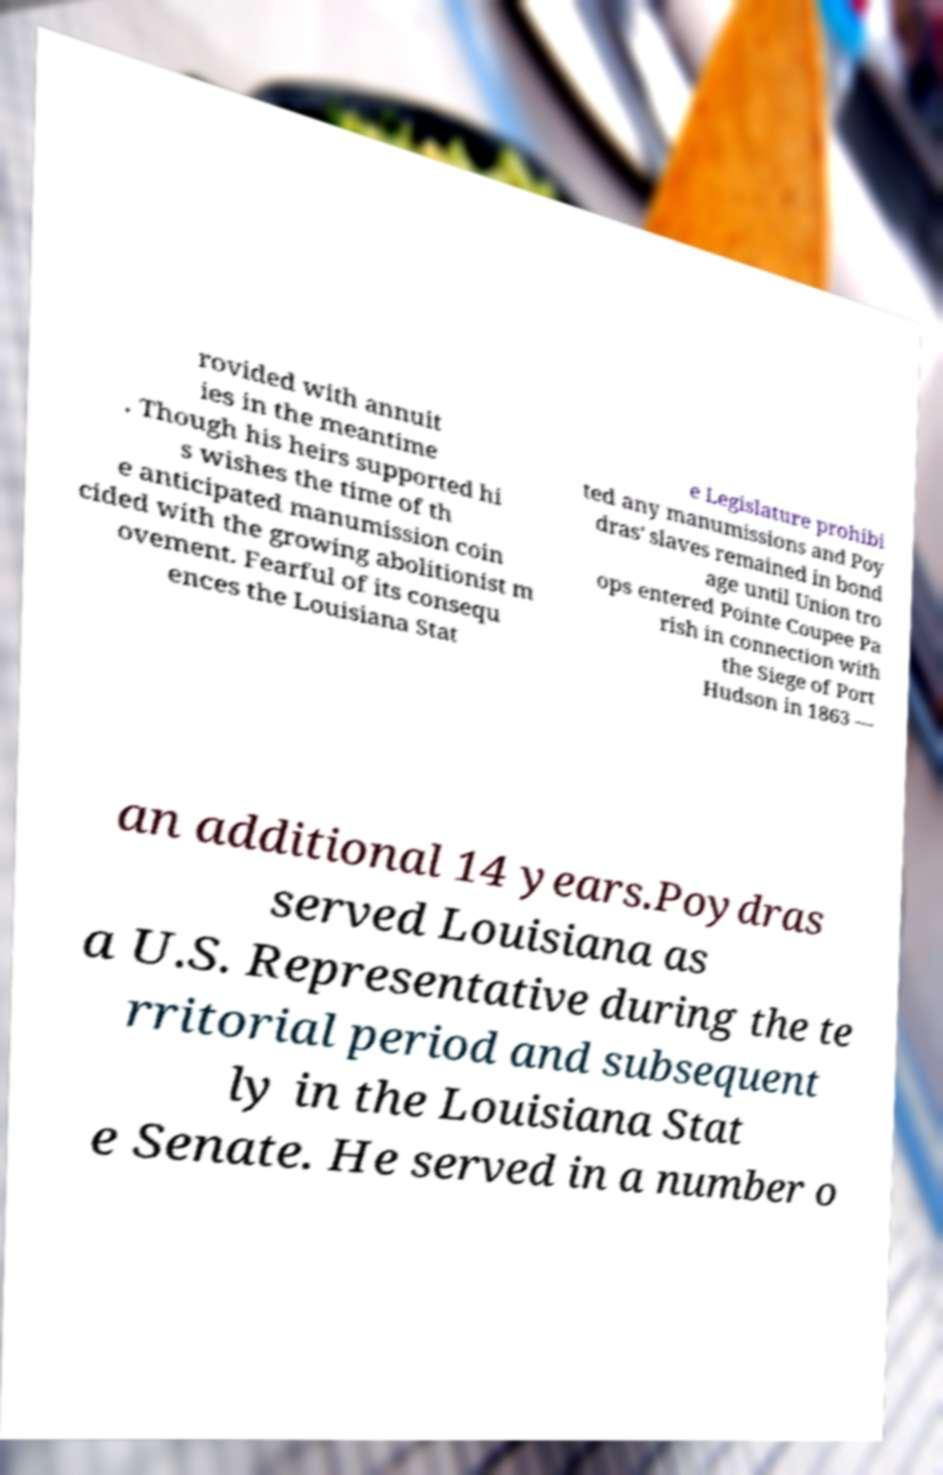Could you assist in decoding the text presented in this image and type it out clearly? rovided with annuit ies in the meantime . Though his heirs supported hi s wishes the time of th e anticipated manumission coin cided with the growing abolitionist m ovement. Fearful of its consequ ences the Louisiana Stat e Legislature prohibi ted any manumissions and Poy dras' slaves remained in bond age until Union tro ops entered Pointe Coupee Pa rish in connection with the Siege of Port Hudson in 1863 — an additional 14 years.Poydras served Louisiana as a U.S. Representative during the te rritorial period and subsequent ly in the Louisiana Stat e Senate. He served in a number o 